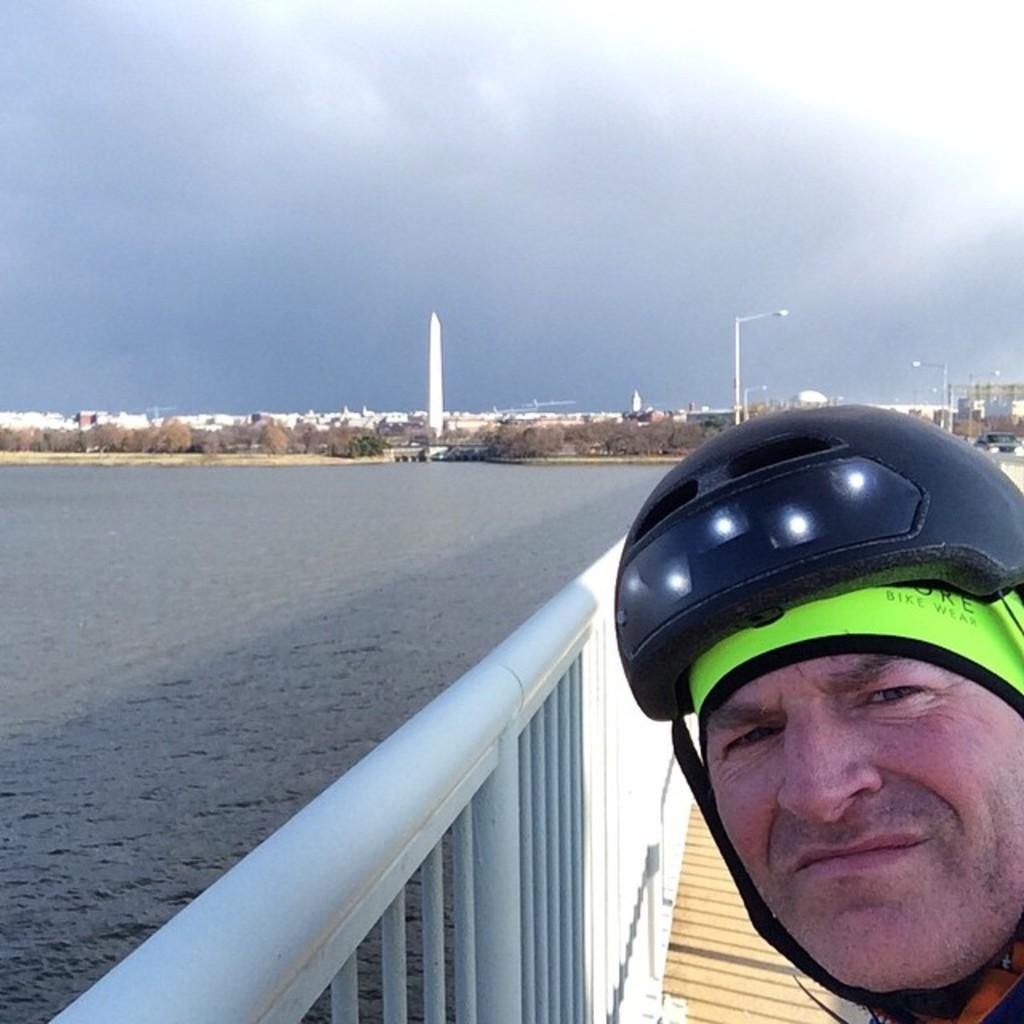What is the person on the right side of the image wearing? The person is wearing a helmet. What can be seen in the image besides the person? There is a railing, water, trees, buildings, towers, poles, and the sky visible in the image. Can you describe the water in the image? The water is visible on the left side of the image. What is visible in the background of the image? Trees, buildings, towers, poles, and the sky are visible in the background of the image. What type of creature is swimming in the waves in the image? There are no waves or creatures visible in the image. What type of linen is draped over the railing in the image? There is no linen present in the image. 